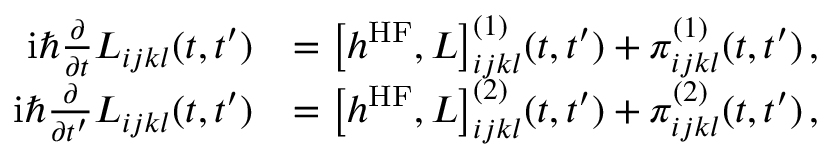Convert formula to latex. <formula><loc_0><loc_0><loc_500><loc_500>\begin{array} { r l } { i \hbar { } \partial } { \partial t } L _ { i j k l } ( t , t ^ { \prime } ) } & { = \left [ h ^ { H F } , L \right ] _ { i j k l } ^ { ( 1 ) } ( t , t ^ { \prime } ) + \pi _ { i j k l } ^ { ( 1 ) } ( t , t ^ { \prime } ) \, , \, } \\ { i \hbar { } \partial } { \partial t ^ { \prime } } L _ { i j k l } ( t , t ^ { \prime } ) } & { = \left [ h ^ { H F } , L \right ] _ { i j k l } ^ { ( 2 ) } ( t , t ^ { \prime } ) + \pi _ { i j k l } ^ { ( 2 ) } ( t , t ^ { \prime } ) \, , \, } \end{array}</formula> 